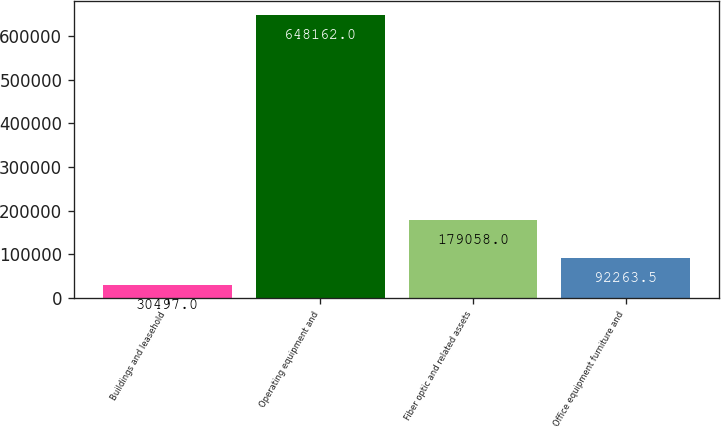Convert chart. <chart><loc_0><loc_0><loc_500><loc_500><bar_chart><fcel>Buildings and leasehold<fcel>Operating equipment and<fcel>Fiber optic and related assets<fcel>Office equipment furniture and<nl><fcel>30497<fcel>648162<fcel>179058<fcel>92263.5<nl></chart> 